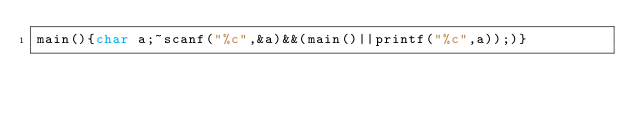<code> <loc_0><loc_0><loc_500><loc_500><_C_>main(){char a;~scanf("%c",&a)&&(main()||printf("%c",a));)}</code> 